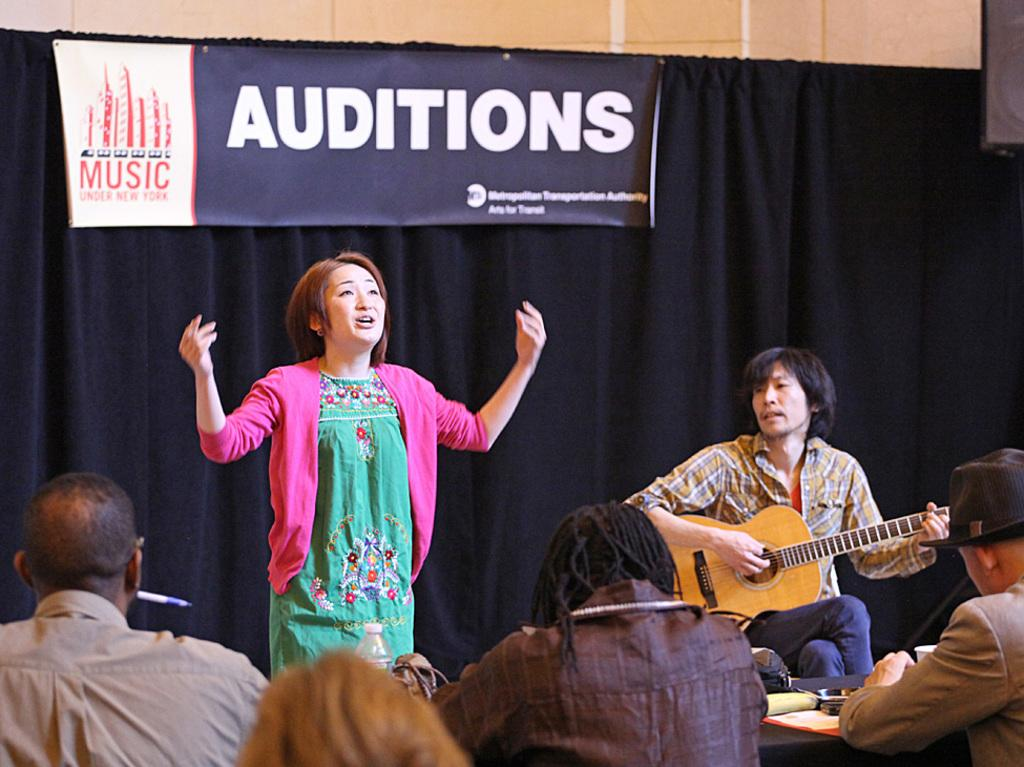What is the main subject of the image? The main subject of the image is a group of people. Can you describe the woman in the image? A woman is standing in the image. What is the man on the right side of the image holding? The man on the right side of the image is holding a guitar. How many girls are sitting on top of the guitar in the image? There are no girls sitting on top of the guitar in the image, as the guitar is being held by a man and there are no girls mentioned in the facts provided. 